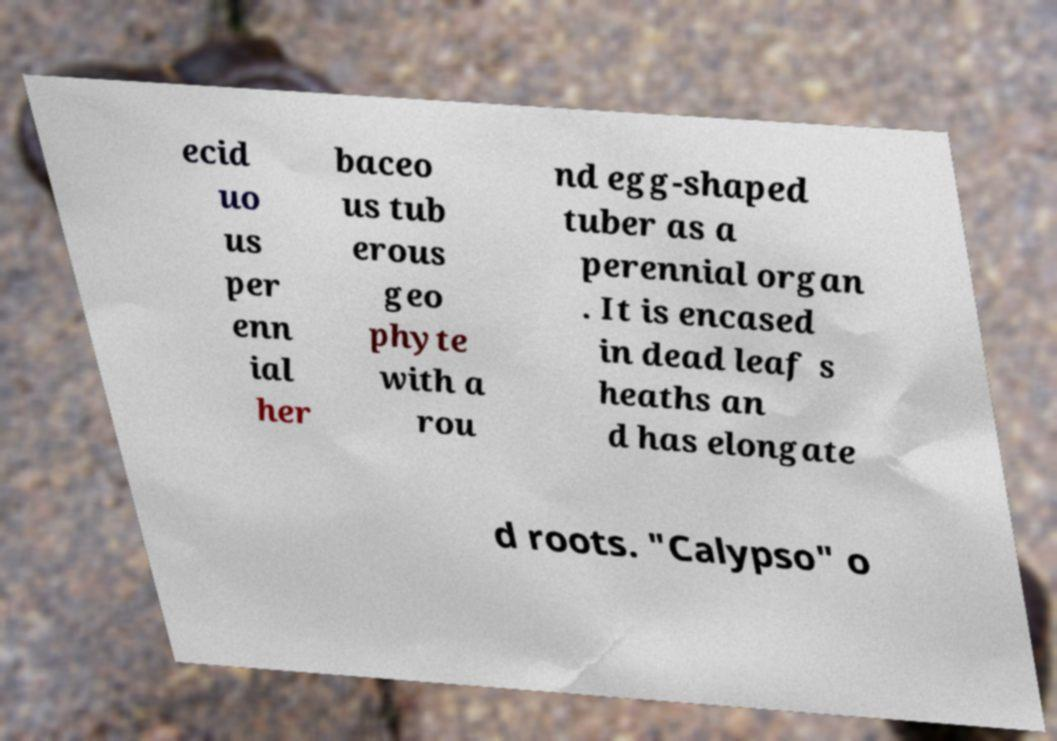Could you assist in decoding the text presented in this image and type it out clearly? ecid uo us per enn ial her baceo us tub erous geo phyte with a rou nd egg-shaped tuber as a perennial organ . It is encased in dead leaf s heaths an d has elongate d roots. "Calypso" o 